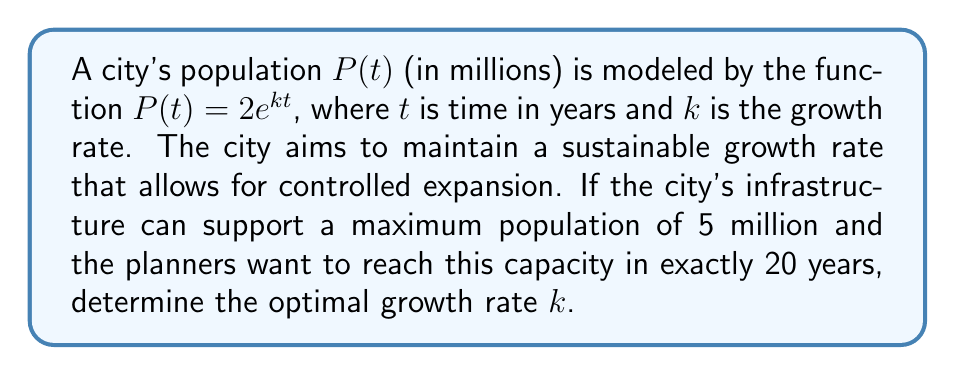Solve this math problem. To solve this problem, we'll follow these steps:

1) We know that at $t = 20$ years, the population should be 5 million. Let's use this information in our equation:

   $P(20) = 5 = 2e^{k(20)}$

2) Divide both sides by 2:

   $\frac{5}{2} = e^{20k}$

3) Take the natural logarithm of both sides:

   $\ln(\frac{5}{2}) = \ln(e^{20k})$

4) Simplify the right side using the properties of logarithms:

   $\ln(\frac{5}{2}) = 20k$

5) Solve for $k$:

   $k = \frac{\ln(\frac{5}{2})}{20}$

6) Calculate the value:

   $k = \frac{\ln(2.5)}{20} \approx 0.0456$

This growth rate will allow the city to reach its maximum sustainable population in exactly 20 years.
Answer: $k \approx 0.0456$ or $4.56\%$ per year 